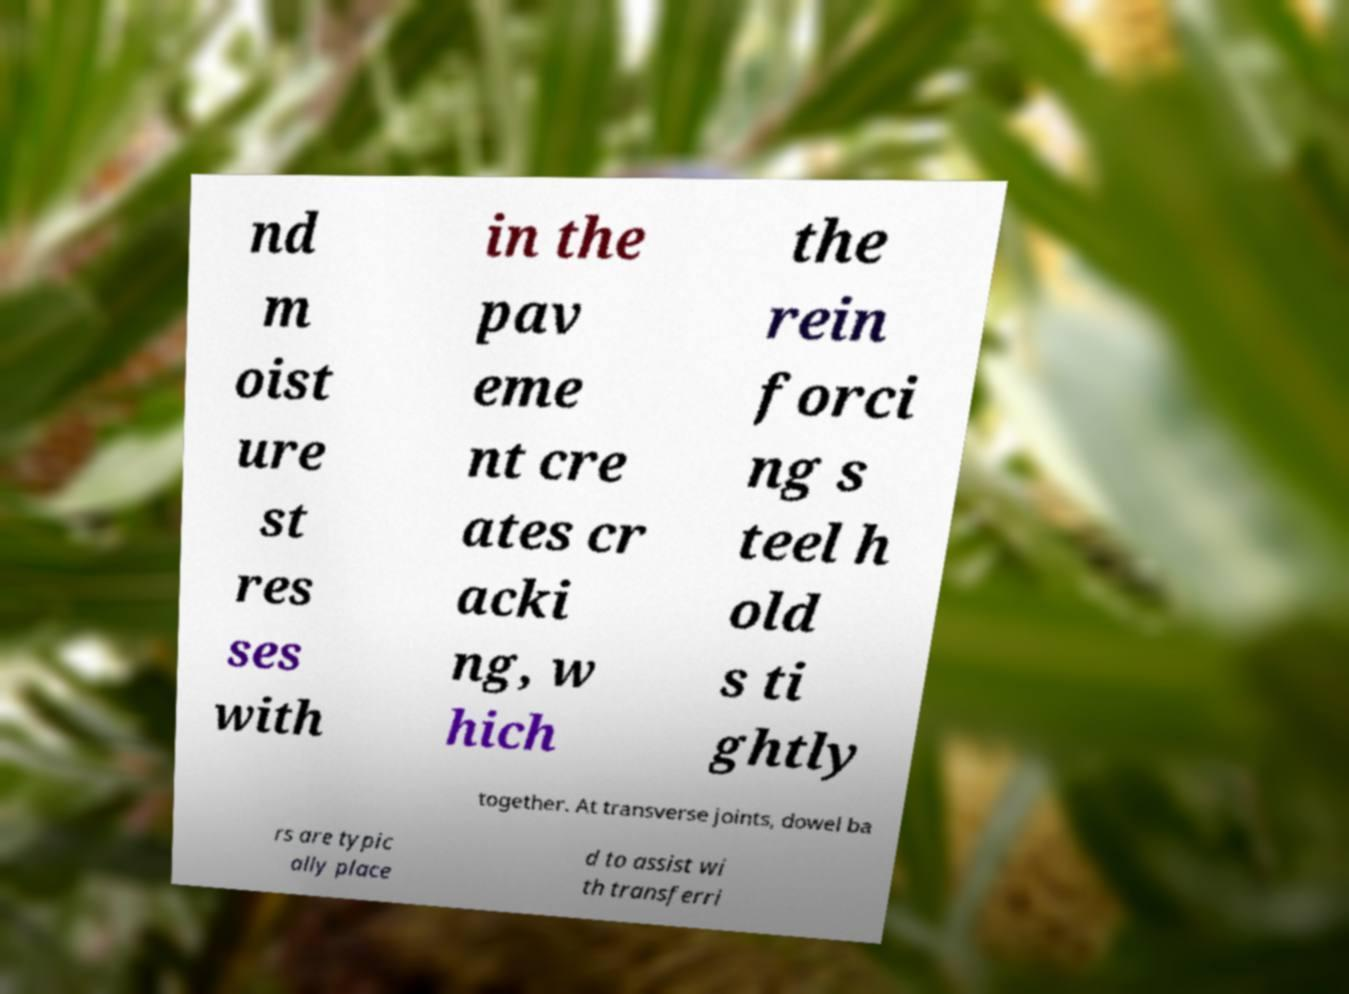I need the written content from this picture converted into text. Can you do that? nd m oist ure st res ses with in the pav eme nt cre ates cr acki ng, w hich the rein forci ng s teel h old s ti ghtly together. At transverse joints, dowel ba rs are typic ally place d to assist wi th transferri 